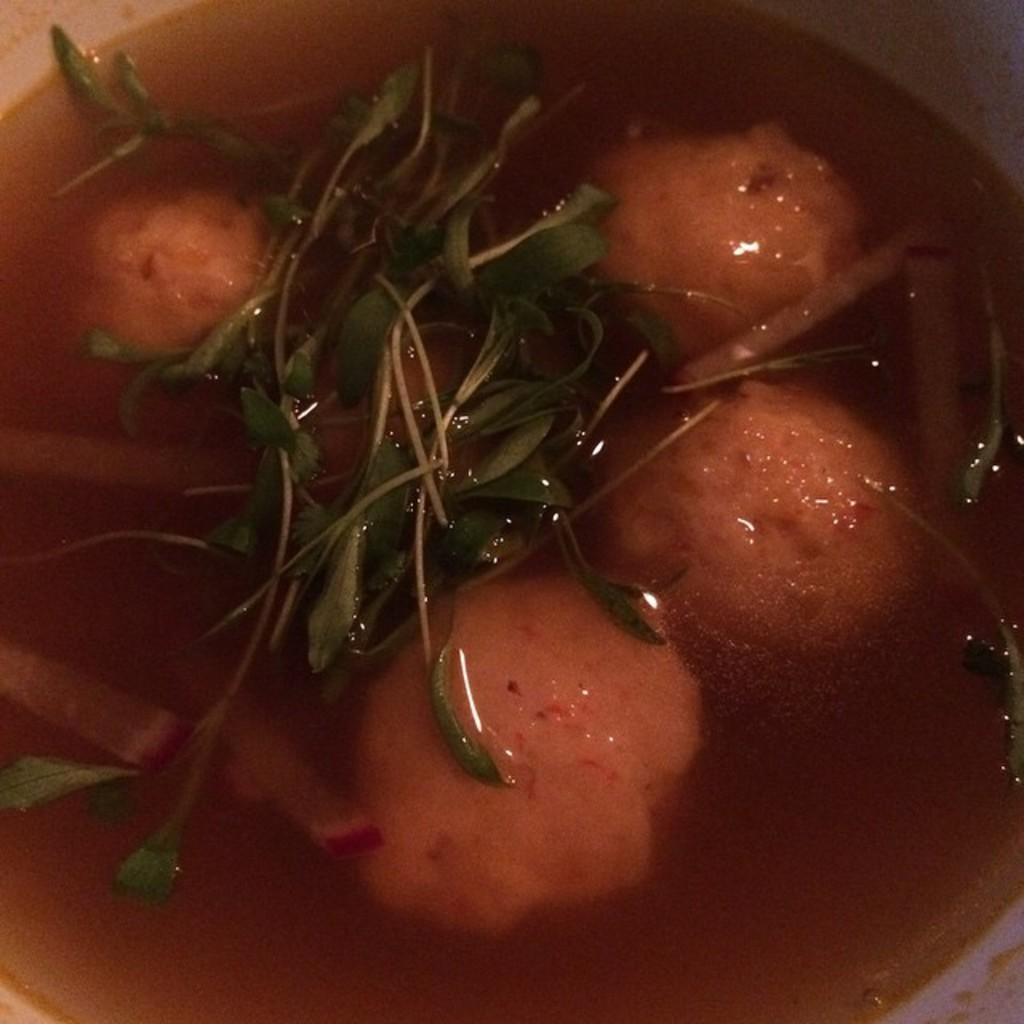What type of food is present in the image? There are leafy vegetables and a food item in a soup in the image. How are the leafy vegetables and food item arranged in the image? The leafy vegetables and food item are in a bowl. Can you describe the food item in the soup? Unfortunately, the specific food item in the soup cannot be determined from the provided facts. What type of air is visible in the image? There is no air visible in the image; the focus is on the food items in the bowl. 